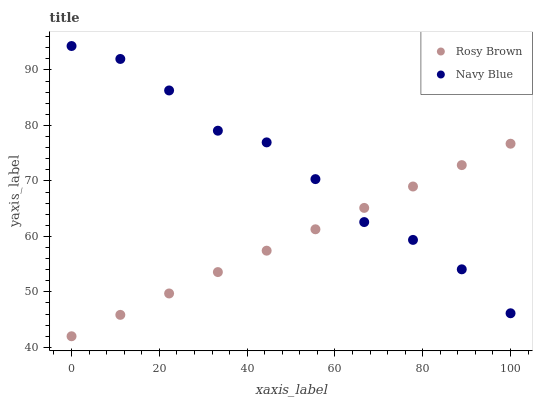Does Rosy Brown have the minimum area under the curve?
Answer yes or no. Yes. Does Navy Blue have the maximum area under the curve?
Answer yes or no. Yes. Does Rosy Brown have the maximum area under the curve?
Answer yes or no. No. Is Rosy Brown the smoothest?
Answer yes or no. Yes. Is Navy Blue the roughest?
Answer yes or no. Yes. Is Rosy Brown the roughest?
Answer yes or no. No. Does Rosy Brown have the lowest value?
Answer yes or no. Yes. Does Navy Blue have the highest value?
Answer yes or no. Yes. Does Rosy Brown have the highest value?
Answer yes or no. No. Does Navy Blue intersect Rosy Brown?
Answer yes or no. Yes. Is Navy Blue less than Rosy Brown?
Answer yes or no. No. Is Navy Blue greater than Rosy Brown?
Answer yes or no. No. 